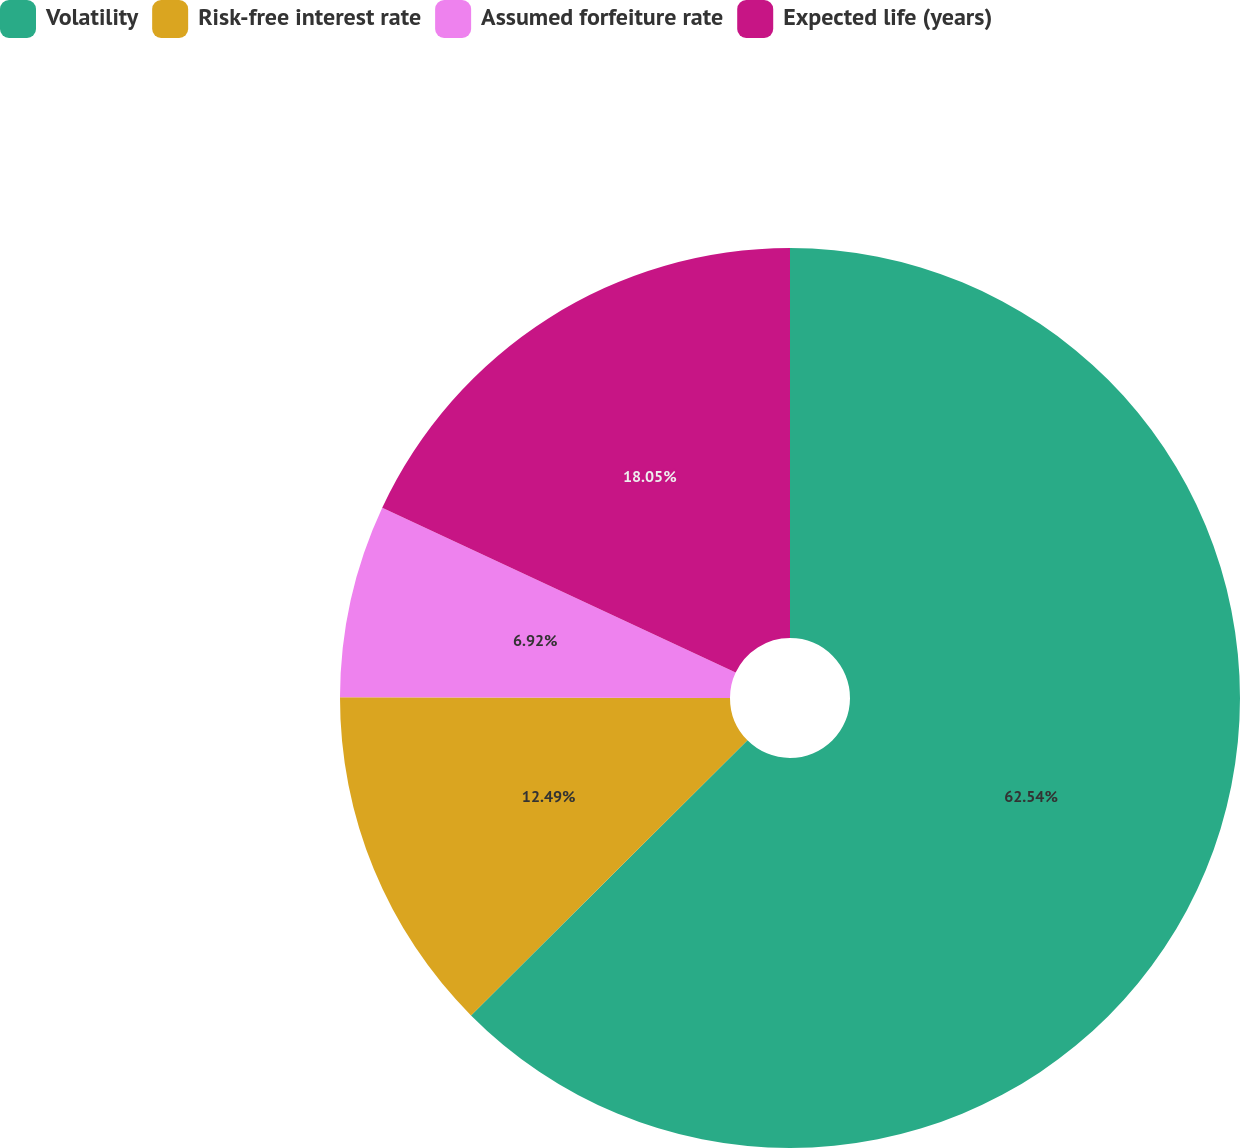<chart> <loc_0><loc_0><loc_500><loc_500><pie_chart><fcel>Volatility<fcel>Risk-free interest rate<fcel>Assumed forfeiture rate<fcel>Expected life (years)<nl><fcel>62.54%<fcel>12.49%<fcel>6.92%<fcel>18.05%<nl></chart> 